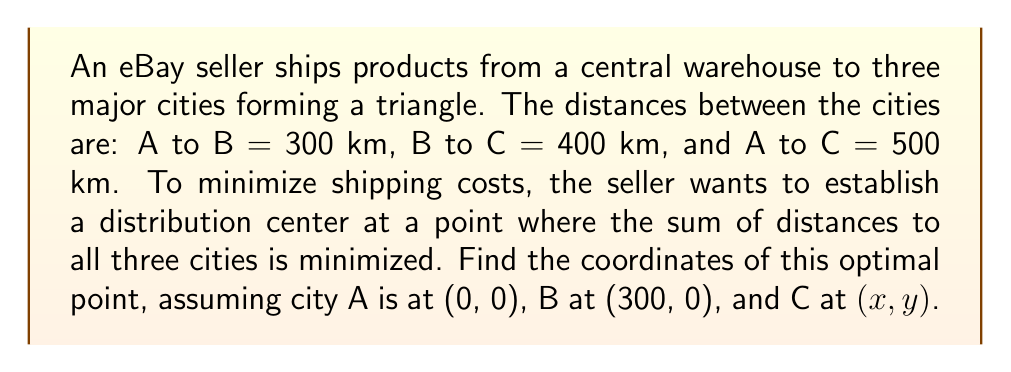Give your solution to this math problem. Let's approach this step-by-step:

1) This is a classic Fermat point problem in geometric optimization.

2) The optimal point is known as the Fermat point or the geometric median.

3) For a triangle where all angles are less than 120°, the Fermat point is located such that the lines connecting it to the triangle's vertices form 120° angles with each other.

4) To find the coordinates, we can use the following formulas:

   $$x = \frac{ax_A + bx_B + cx_C}{a + b + c}$$
   $$y = \frac{ay_A + by_B + cy_C}{a + b + c}$$

   Where $(x_A, y_A)$, $(x_B, y_B)$, and $(x_C, y_C)$ are the coordinates of points A, B, and C respectively, and:

   $$a = \frac{\sin(\angle BAC + 60°)}{\sin(\angle BAC)}$$
   $$b = \frac{\sin(\angle ABC + 60°)}{\sin(\angle ABC)}$$
   $$c = \frac{\sin(\angle BCA + 60°)}{\sin(\angle BCA)}$$

5) First, let's find the coordinates of point C using the given distances:
   
   $$x = 300 - 400\cos(\theta)$$
   $$y = 400\sin(\theta)$$
   
   Where $\theta = \arccos(\frac{300^2 + 400^2 - 500^2}{2 * 300 * 400}) \approx 0.9273$ radians or 53.13°

6) This gives us C ≈ (60.72, 319.62)

7) Now we can calculate the angles:
   
   $\angle BAC \approx 1.5708$ radians (90°)
   $\angle ABC \approx 0.9273$ radians (53.13°)
   $\angle BCA \approx 0.6435$ radians (36.87°)

8) Using these angles, we can calculate a, b, and c:

   $a \approx 1.7321$
   $b \approx 2.5166$
   $c \approx 1.7321$

9) Finally, we can use the formulas from step 4 to find the coordinates of the Fermat point:

   $$x = \frac{1.7321 * 0 + 2.5166 * 300 + 1.7321 * 60.72}{1.7321 + 2.5166 + 1.7321} \approx 127.04$$
   $$y = \frac{1.7321 * 0 + 2.5166 * 0 + 1.7321 * 319.62}{1.7321 + 2.5166 + 1.7321} \approx 92.54$$

Therefore, the optimal location for the distribution center is approximately (127.04, 92.54).
Answer: (127.04, 92.54) 